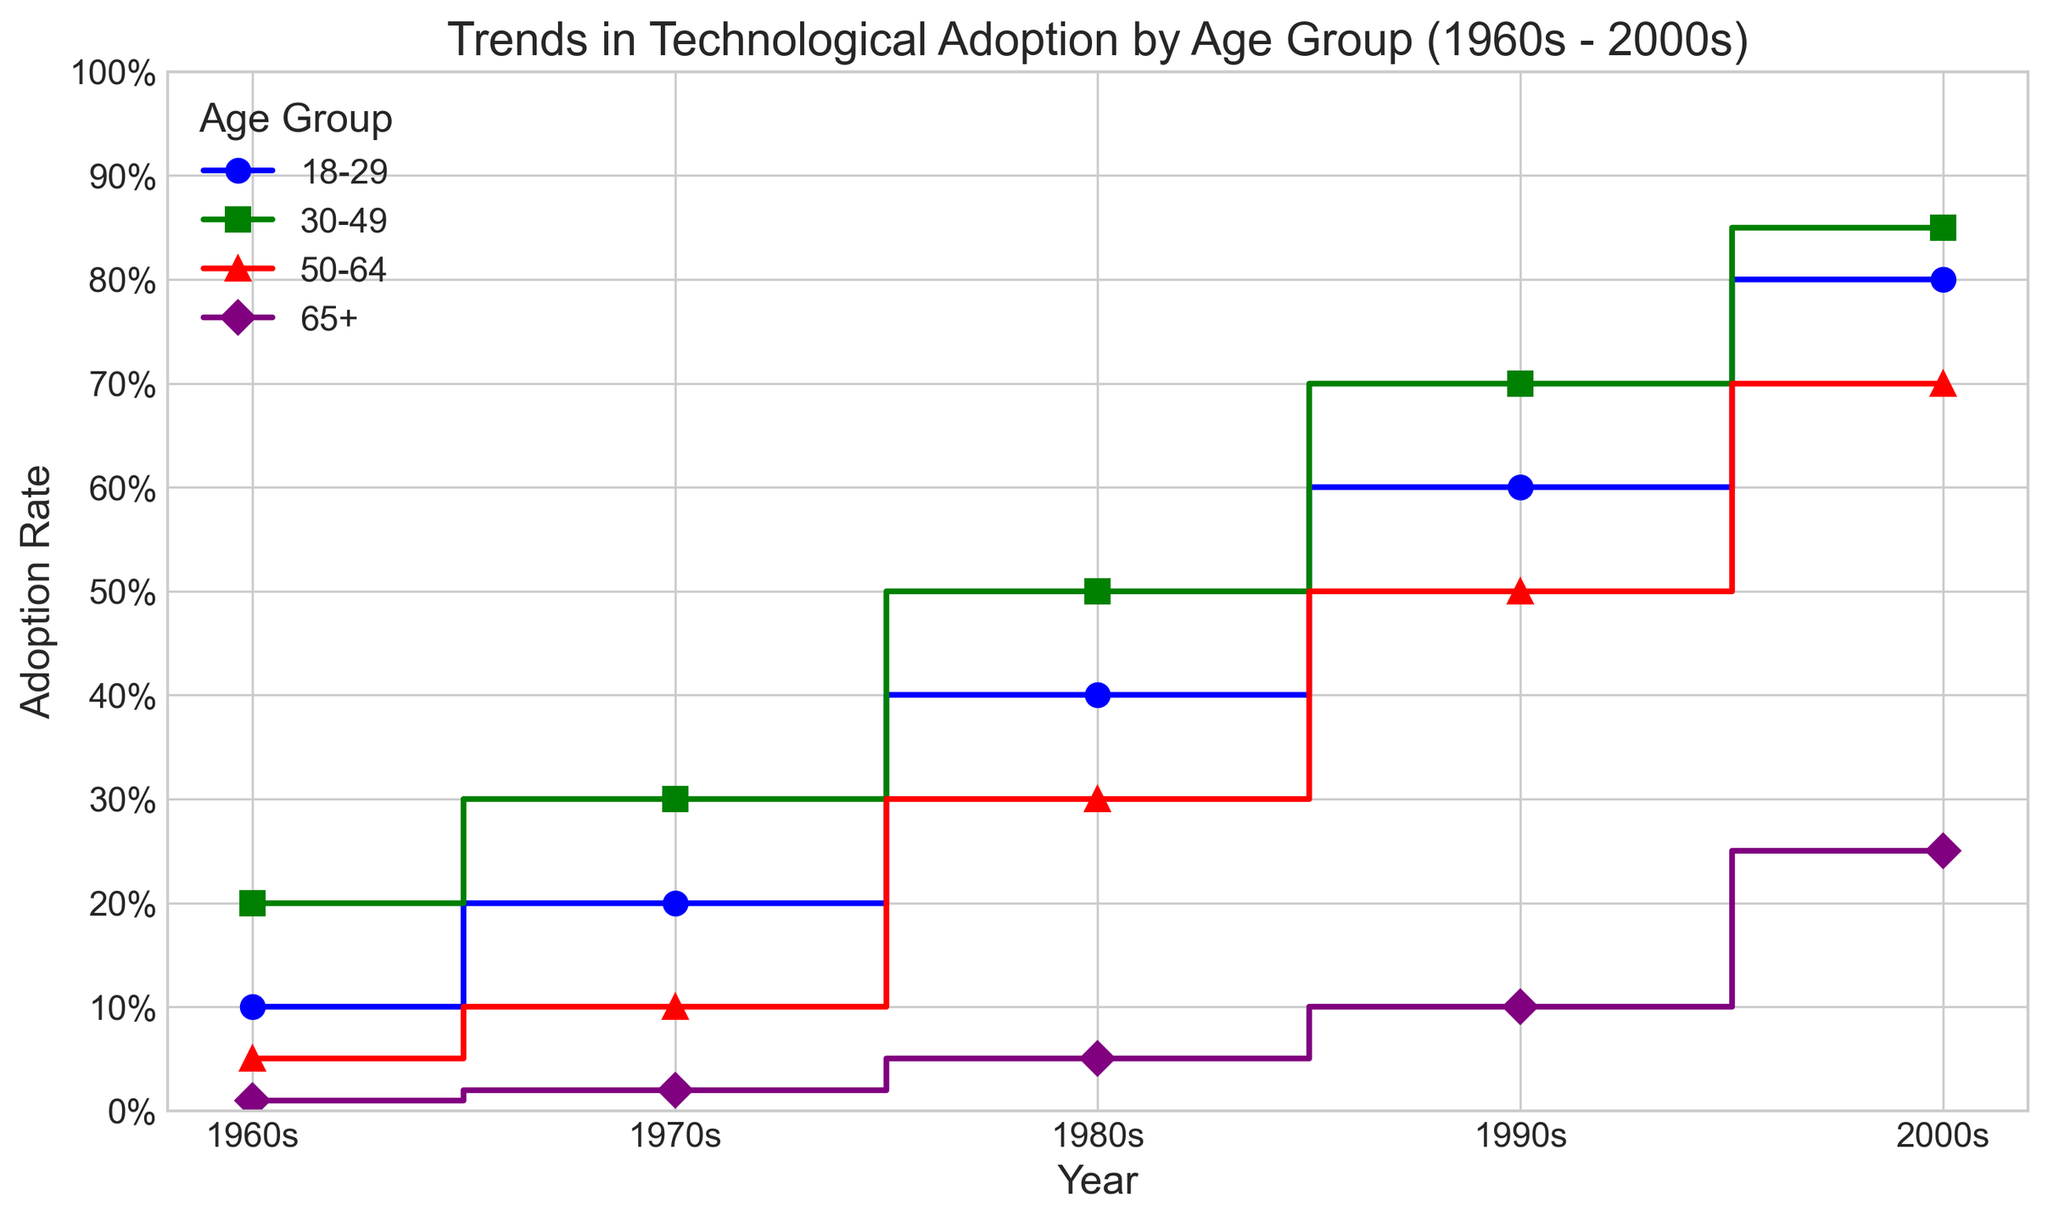What age group saw the largest increase in adoption rate from the 1960s to the 2000s? To determine this, we first find the adoption rates for all age groups in the 1960s and 2000s. The largest increase can be observed by subtracting the 1960s adoption rate from the 2000s adoption rate for each age group. For 18-29, the increase is 0.80 - 0.10 = 0.70. For 30-49, it's 0.85 - 0.20 = 0.65. For 50-64, it's 0.70 - 0.05 = 0.65. For 65+, it's 0.25 - 0.01 = 0.24. The largest increase is for the 18-29 age group with an increase of 0.70.
Answer: 18-29 In which decade did the 65+ age group first surpass 10% adoption rate? Looking at the adoption rates for the 65+ age group across the decades: 1960s (0.01), 1970s (0.02), 1980s (0.05), 1990s (0.10), 2000s (0.25). The first decade where the adoption rate surpassed 10% is the 2000s.
Answer: 2000s Which age group had the highest adoption rate in the 1990s? By examining the adoption rates for each age group in the 1990s: 18-29 (0.60), 30-49 (0.70), 50-64 (0.50), 65+ (0.10). The 30-49 age group had the highest adoption rate in the 1990s with 0.70.
Answer: 30-49 How does the adoption rate of the 50-64 age group in the 2000s compare to the 18-29 age group in the 1980s? From the data, the adoption rate of the 50-64 age group in the 2000s is 0.70. The adoption rate for the 18-29 age group in the 1980s is 0.40. Comparing these, 0.70 is higher than 0.40.
Answer: 0.70 is higher What is the average adoption rate of all age groups in the 1970s? Summing the adoption rates in the 1970s: 18-29 (0.20), 30-49 (0.30), 50-64 (0.10), 65+ (0.02). The total is 0.20 + 0.30 + 0.10 + 0.02 = 0.62. Average is 0.62 / 4 = 0.155.
Answer: 0.155 How much did the adoption rate for the 18-29 age group increase from the 1980s to the 1990s? The adoption rate for the 18-29 age group was 0.40 in the 1980s and 0.60 in the 1990s. The increase is 0.60 - 0.40 = 0.20.
Answer: 0.20 Which decade saw the biggest improvement in the adoption rate for the 30-49 age group? The adoption rates for the 30-49 age group are: 1960s (0.20), 1970s (0.30), 1980s (0.50), 1990s (0.70), 2000s (0.85). The increments are 1970s-1960s (0.10), 1980s-1970s (0.20), 1990s-1980s (0.20), 2000s-1990s (0.15). The biggest improvement was from the 1980s to the 1990s.
Answer: 1980s to 1990s 